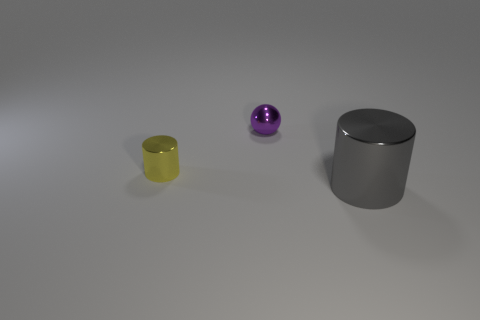Are there any large gray cylinders that have the same material as the tiny cylinder?
Provide a short and direct response. Yes. Do the small purple object and the yellow shiny object have the same shape?
Offer a terse response. No. What shape is the metal object to the left of the tiny thing behind the small yellow thing?
Provide a short and direct response. Cylinder. There is a purple shiny sphere; does it have the same size as the cylinder behind the big object?
Your response must be concise. Yes. There is a metallic thing that is in front of the small object that is in front of the small thing on the right side of the tiny yellow object; how big is it?
Ensure brevity in your answer.  Large. How many cylinders are behind the cylinder in front of the yellow shiny object?
Provide a succinct answer. 1. What is the size of the object that is both in front of the small purple shiny object and to the right of the yellow cylinder?
Make the answer very short. Large. What shape is the metal object that is both behind the gray metal thing and in front of the shiny ball?
Keep it short and to the point. Cylinder. Is there a tiny purple object left of the thing in front of the tiny yellow metal thing to the left of the tiny metal ball?
Ensure brevity in your answer.  Yes. What number of things are shiny cylinders that are on the left side of the large thing or tiny objects that are on the left side of the shiny sphere?
Provide a succinct answer. 1. 